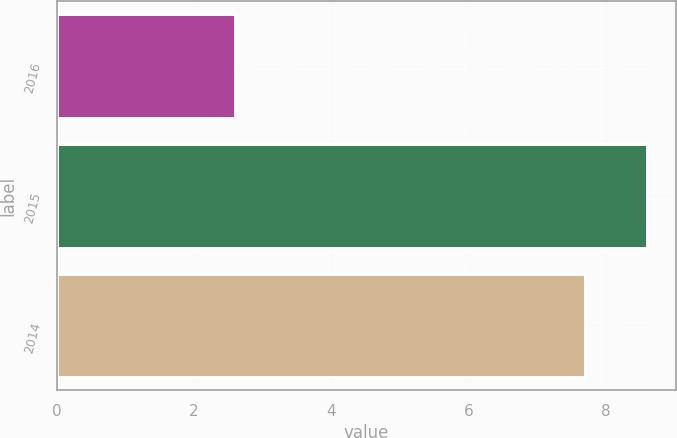Convert chart. <chart><loc_0><loc_0><loc_500><loc_500><bar_chart><fcel>2016<fcel>2015<fcel>2014<nl><fcel>2.6<fcel>8.6<fcel>7.7<nl></chart> 